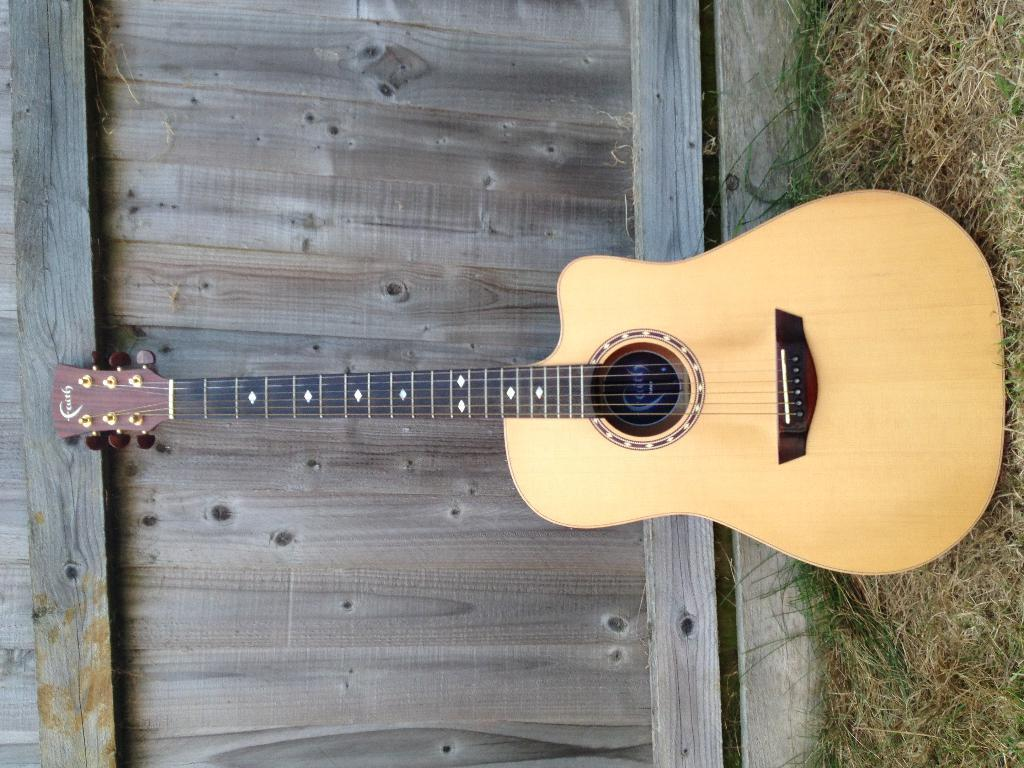What musical instrument is present in the image? There is a guitar in the image. What type of natural environment can be seen in the image? There is grass visible in the image. What type of material is used for the wall in the image? There is a wooden wall in the image. What type of mice can be seen playing the guitar in the image? There are no mice present in the image, and therefore no such activity can be observed. 